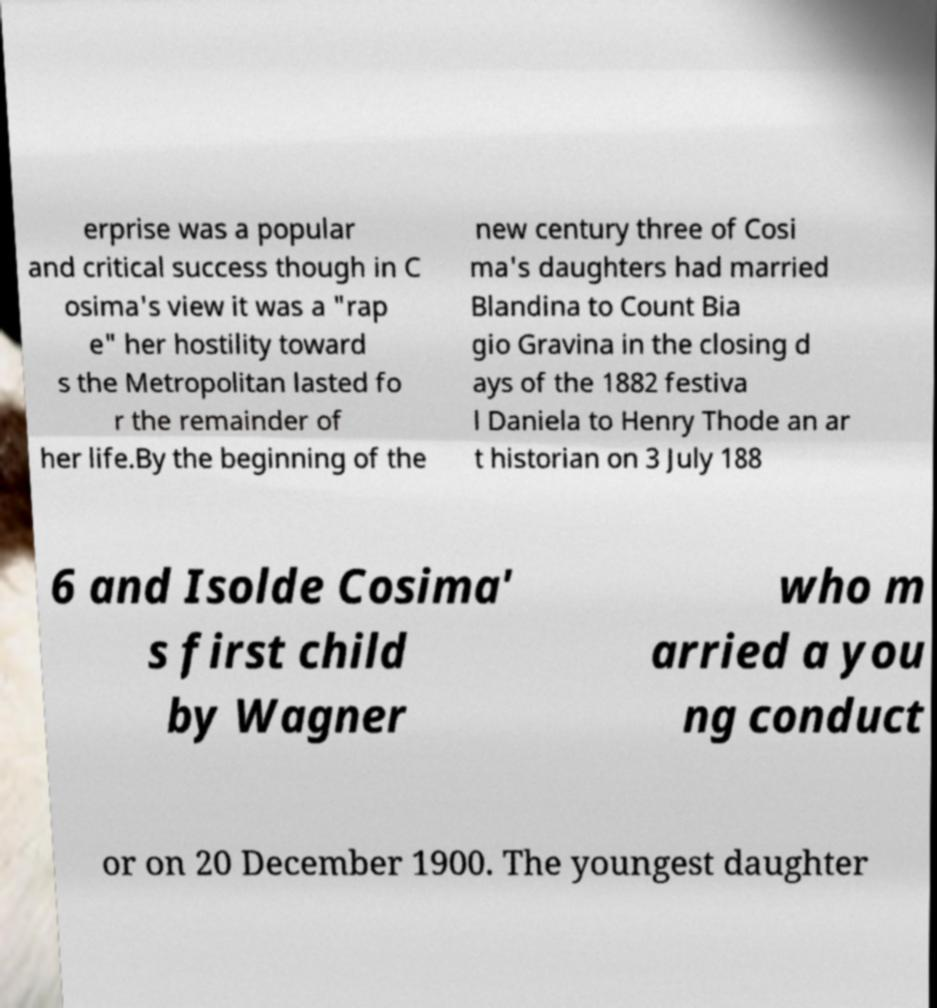What messages or text are displayed in this image? I need them in a readable, typed format. erprise was a popular and critical success though in C osima's view it was a "rap e" her hostility toward s the Metropolitan lasted fo r the remainder of her life.By the beginning of the new century three of Cosi ma's daughters had married Blandina to Count Bia gio Gravina in the closing d ays of the 1882 festiva l Daniela to Henry Thode an ar t historian on 3 July 188 6 and Isolde Cosima' s first child by Wagner who m arried a you ng conduct or on 20 December 1900. The youngest daughter 